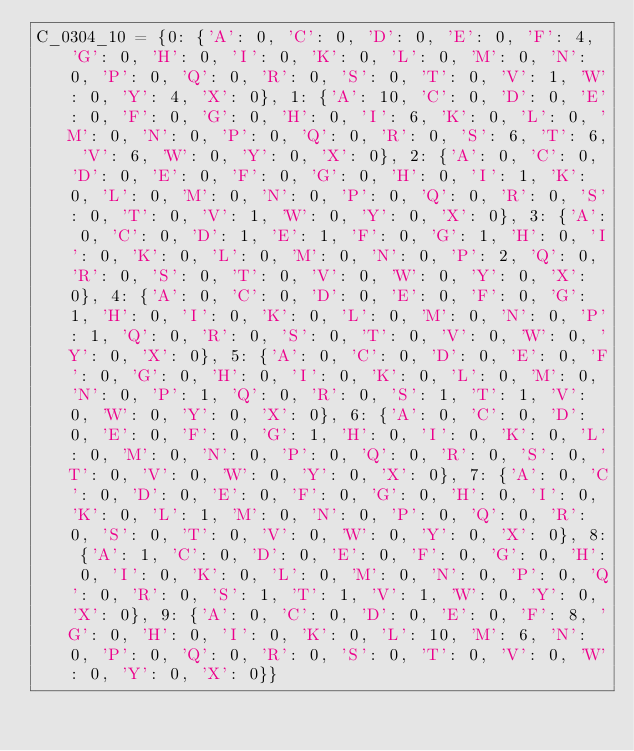<code> <loc_0><loc_0><loc_500><loc_500><_Python_>C_0304_10 = {0: {'A': 0, 'C': 0, 'D': 0, 'E': 0, 'F': 4, 'G': 0, 'H': 0, 'I': 0, 'K': 0, 'L': 0, 'M': 0, 'N': 0, 'P': 0, 'Q': 0, 'R': 0, 'S': 0, 'T': 0, 'V': 1, 'W': 0, 'Y': 4, 'X': 0}, 1: {'A': 10, 'C': 0, 'D': 0, 'E': 0, 'F': 0, 'G': 0, 'H': 0, 'I': 6, 'K': 0, 'L': 0, 'M': 0, 'N': 0, 'P': 0, 'Q': 0, 'R': 0, 'S': 6, 'T': 6, 'V': 6, 'W': 0, 'Y': 0, 'X': 0}, 2: {'A': 0, 'C': 0, 'D': 0, 'E': 0, 'F': 0, 'G': 0, 'H': 0, 'I': 1, 'K': 0, 'L': 0, 'M': 0, 'N': 0, 'P': 0, 'Q': 0, 'R': 0, 'S': 0, 'T': 0, 'V': 1, 'W': 0, 'Y': 0, 'X': 0}, 3: {'A': 0, 'C': 0, 'D': 1, 'E': 1, 'F': 0, 'G': 1, 'H': 0, 'I': 0, 'K': 0, 'L': 0, 'M': 0, 'N': 0, 'P': 2, 'Q': 0, 'R': 0, 'S': 0, 'T': 0, 'V': 0, 'W': 0, 'Y': 0, 'X': 0}, 4: {'A': 0, 'C': 0, 'D': 0, 'E': 0, 'F': 0, 'G': 1, 'H': 0, 'I': 0, 'K': 0, 'L': 0, 'M': 0, 'N': 0, 'P': 1, 'Q': 0, 'R': 0, 'S': 0, 'T': 0, 'V': 0, 'W': 0, 'Y': 0, 'X': 0}, 5: {'A': 0, 'C': 0, 'D': 0, 'E': 0, 'F': 0, 'G': 0, 'H': 0, 'I': 0, 'K': 0, 'L': 0, 'M': 0, 'N': 0, 'P': 1, 'Q': 0, 'R': 0, 'S': 1, 'T': 1, 'V': 0, 'W': 0, 'Y': 0, 'X': 0}, 6: {'A': 0, 'C': 0, 'D': 0, 'E': 0, 'F': 0, 'G': 1, 'H': 0, 'I': 0, 'K': 0, 'L': 0, 'M': 0, 'N': 0, 'P': 0, 'Q': 0, 'R': 0, 'S': 0, 'T': 0, 'V': 0, 'W': 0, 'Y': 0, 'X': 0}, 7: {'A': 0, 'C': 0, 'D': 0, 'E': 0, 'F': 0, 'G': 0, 'H': 0, 'I': 0, 'K': 0, 'L': 1, 'M': 0, 'N': 0, 'P': 0, 'Q': 0, 'R': 0, 'S': 0, 'T': 0, 'V': 0, 'W': 0, 'Y': 0, 'X': 0}, 8: {'A': 1, 'C': 0, 'D': 0, 'E': 0, 'F': 0, 'G': 0, 'H': 0, 'I': 0, 'K': 0, 'L': 0, 'M': 0, 'N': 0, 'P': 0, 'Q': 0, 'R': 0, 'S': 1, 'T': 1, 'V': 1, 'W': 0, 'Y': 0, 'X': 0}, 9: {'A': 0, 'C': 0, 'D': 0, 'E': 0, 'F': 8, 'G': 0, 'H': 0, 'I': 0, 'K': 0, 'L': 10, 'M': 6, 'N': 0, 'P': 0, 'Q': 0, 'R': 0, 'S': 0, 'T': 0, 'V': 0, 'W': 0, 'Y': 0, 'X': 0}}</code> 